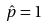<formula> <loc_0><loc_0><loc_500><loc_500>\hat { p } = 1</formula> 